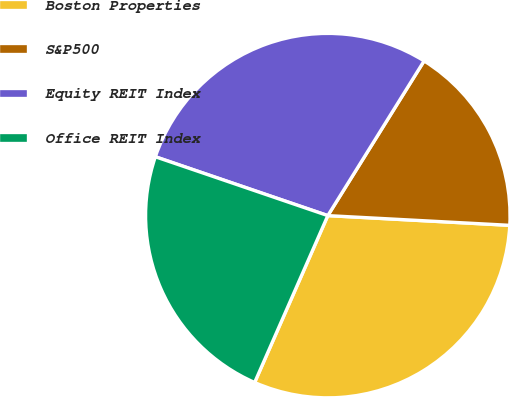<chart> <loc_0><loc_0><loc_500><loc_500><pie_chart><fcel>Boston Properties<fcel>S&P500<fcel>Equity REIT Index<fcel>Office REIT Index<nl><fcel>30.73%<fcel>16.99%<fcel>28.63%<fcel>23.66%<nl></chart> 